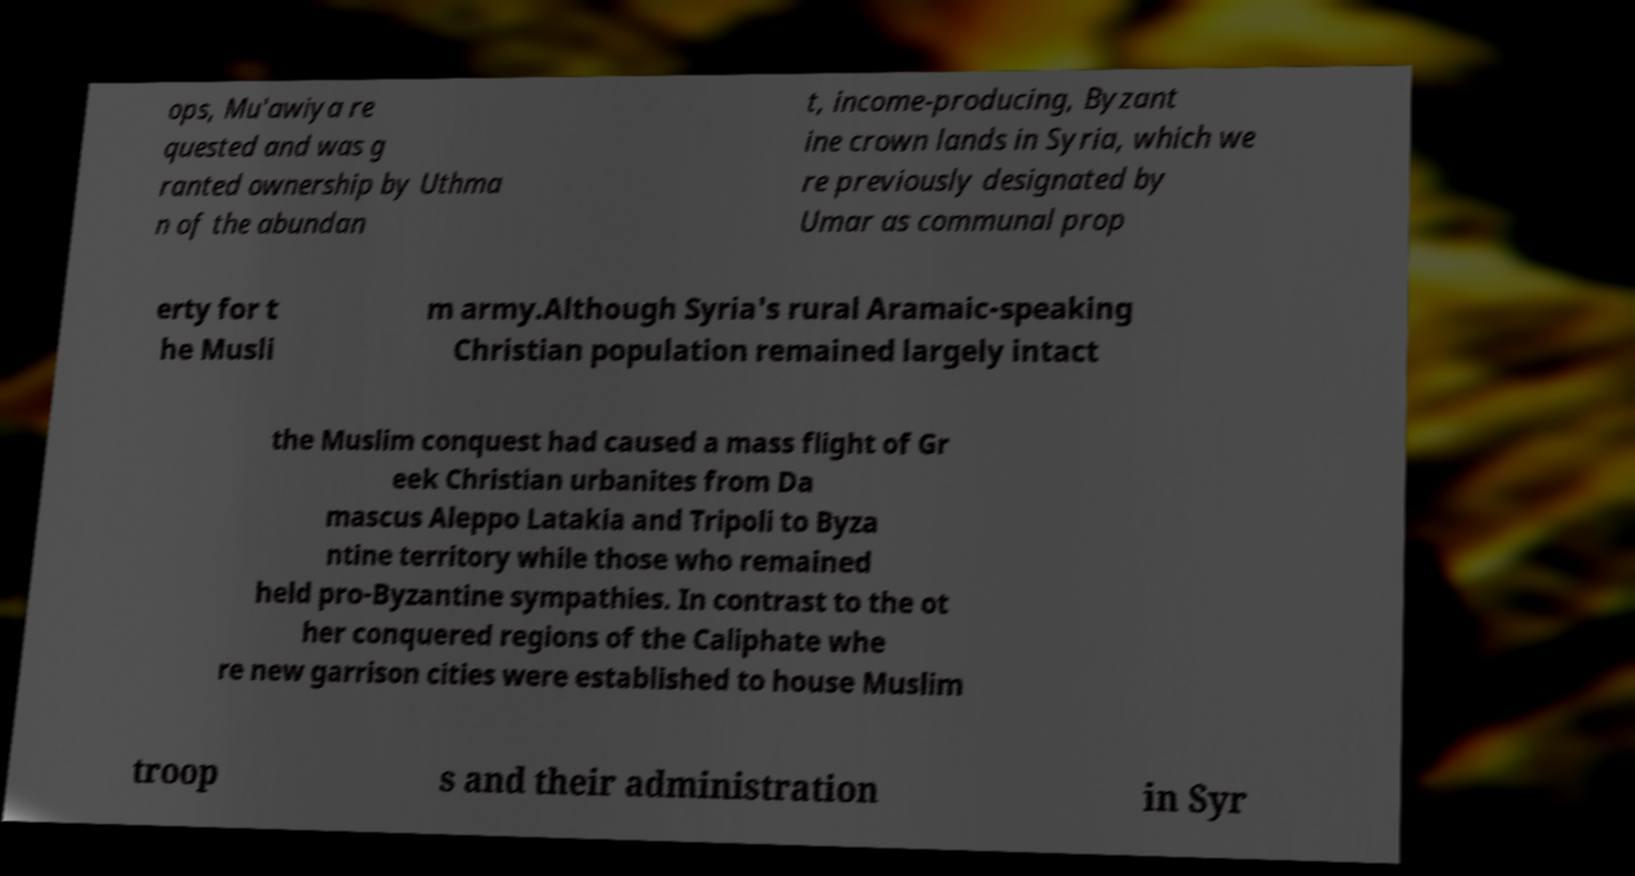Can you accurately transcribe the text from the provided image for me? ops, Mu'awiya re quested and was g ranted ownership by Uthma n of the abundan t, income-producing, Byzant ine crown lands in Syria, which we re previously designated by Umar as communal prop erty for t he Musli m army.Although Syria's rural Aramaic-speaking Christian population remained largely intact the Muslim conquest had caused a mass flight of Gr eek Christian urbanites from Da mascus Aleppo Latakia and Tripoli to Byza ntine territory while those who remained held pro-Byzantine sympathies. In contrast to the ot her conquered regions of the Caliphate whe re new garrison cities were established to house Muslim troop s and their administration in Syr 